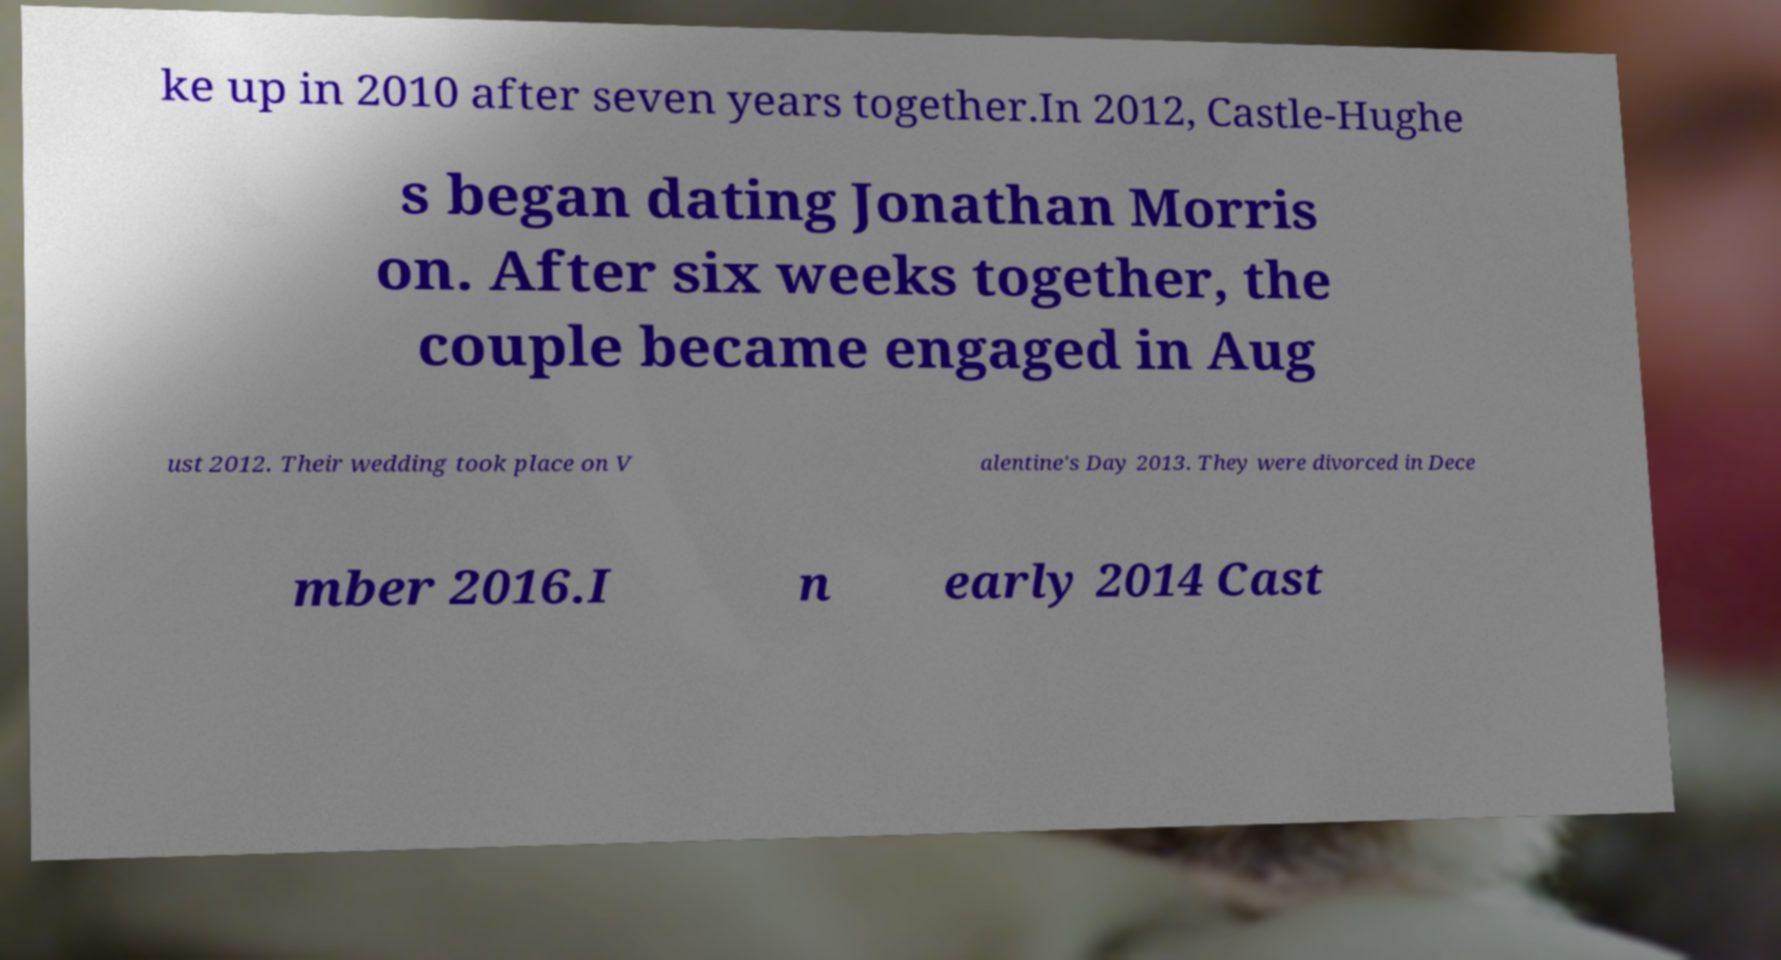For documentation purposes, I need the text within this image transcribed. Could you provide that? ke up in 2010 after seven years together.In 2012, Castle-Hughe s began dating Jonathan Morris on. After six weeks together, the couple became engaged in Aug ust 2012. Their wedding took place on V alentine's Day 2013. They were divorced in Dece mber 2016.I n early 2014 Cast 